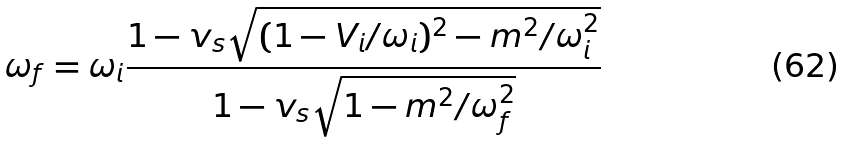<formula> <loc_0><loc_0><loc_500><loc_500>\omega _ { f } = \omega _ { i } \frac { 1 - v _ { s } \sqrt { ( 1 - V _ { i } / \omega _ { i } ) ^ { 2 } - m ^ { 2 } / \omega _ { i } ^ { 2 } } } { 1 - v _ { s } \sqrt { 1 - m ^ { 2 } / \omega _ { f } ^ { 2 } } }</formula> 